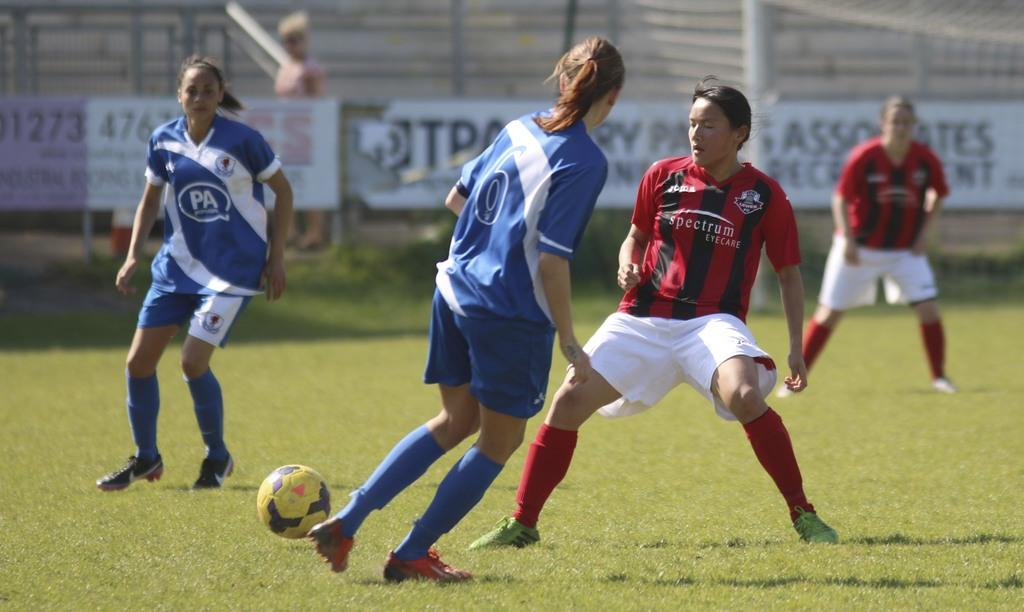How many people are in the image? There are two persons in the image. What are the persons doing in the image? The persons are running, as indicated by leg movement. What object is beside one of the persons? There is a ball beside one of the persons. What type of surface are the persons standing on? The persons are standing on grass. What can be seen in the distance in the image? There are banners in the distance, and they appear to be white. What type of grip does the person have on the ball in the image? There is no person holding a ball in the image; it is beside one of the persons. What type of teeth can be seen in the image? There are no teeth visible in the image. 